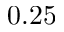<formula> <loc_0><loc_0><loc_500><loc_500>0 . 2 5</formula> 